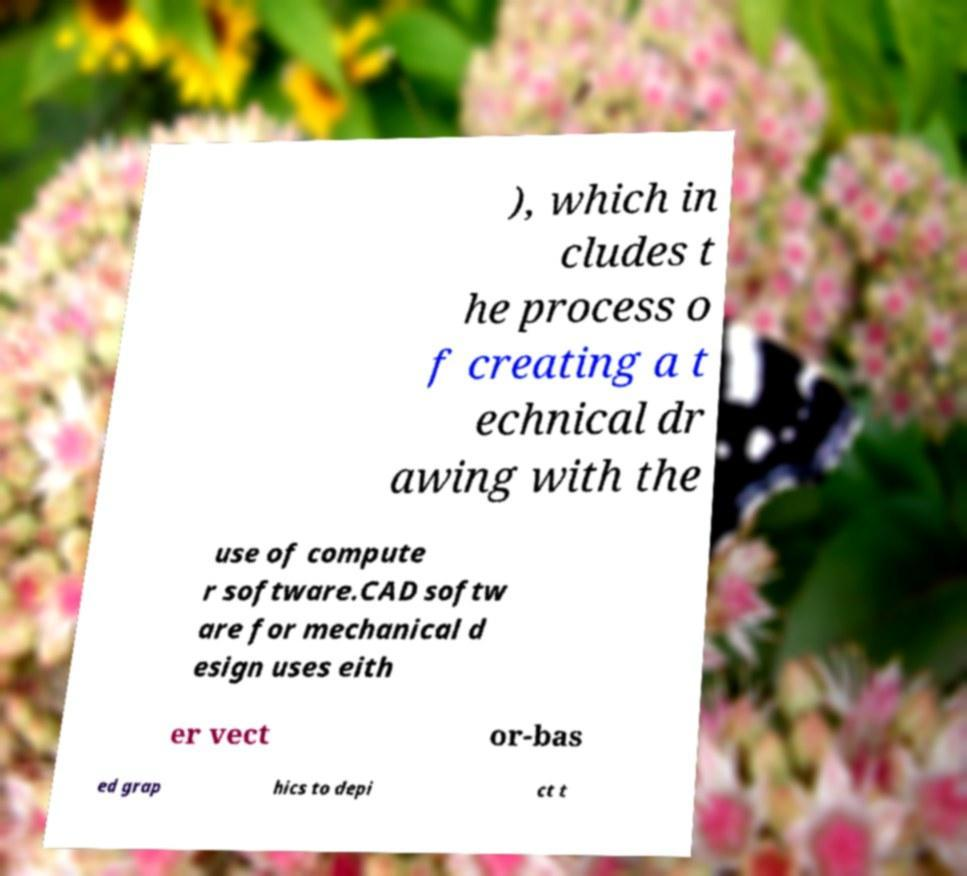Could you extract and type out the text from this image? ), which in cludes t he process o f creating a t echnical dr awing with the use of compute r software.CAD softw are for mechanical d esign uses eith er vect or-bas ed grap hics to depi ct t 